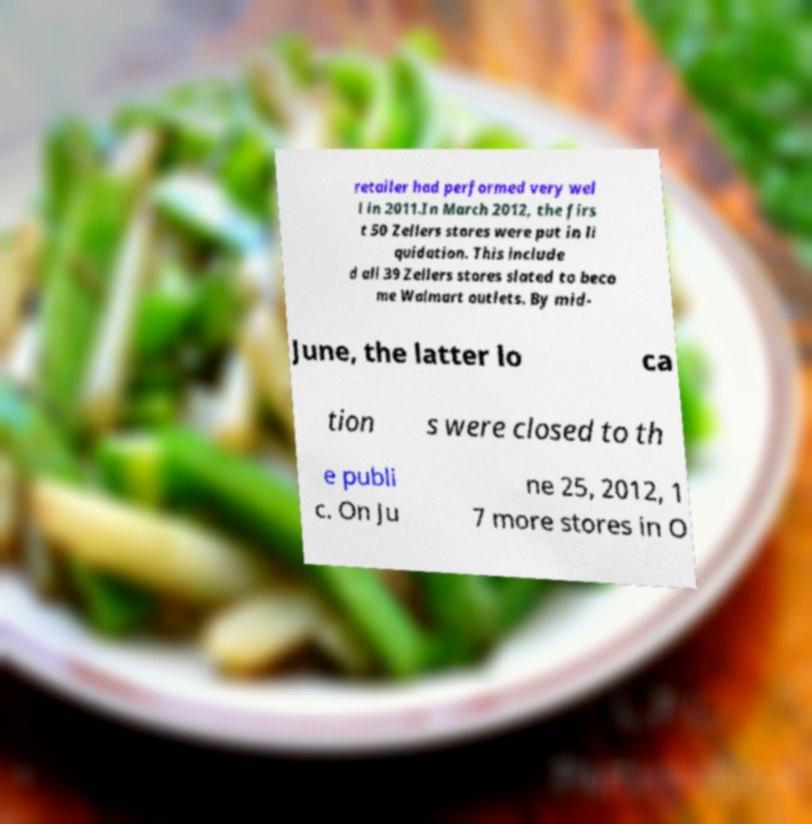What messages or text are displayed in this image? I need them in a readable, typed format. retailer had performed very wel l in 2011.In March 2012, the firs t 50 Zellers stores were put in li quidation. This include d all 39 Zellers stores slated to beco me Walmart outlets. By mid- June, the latter lo ca tion s were closed to th e publi c. On Ju ne 25, 2012, 1 7 more stores in O 